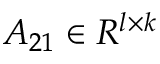Convert formula to latex. <formula><loc_0><loc_0><loc_500><loc_500>A _ { 2 1 } \in R ^ { l \times k }</formula> 